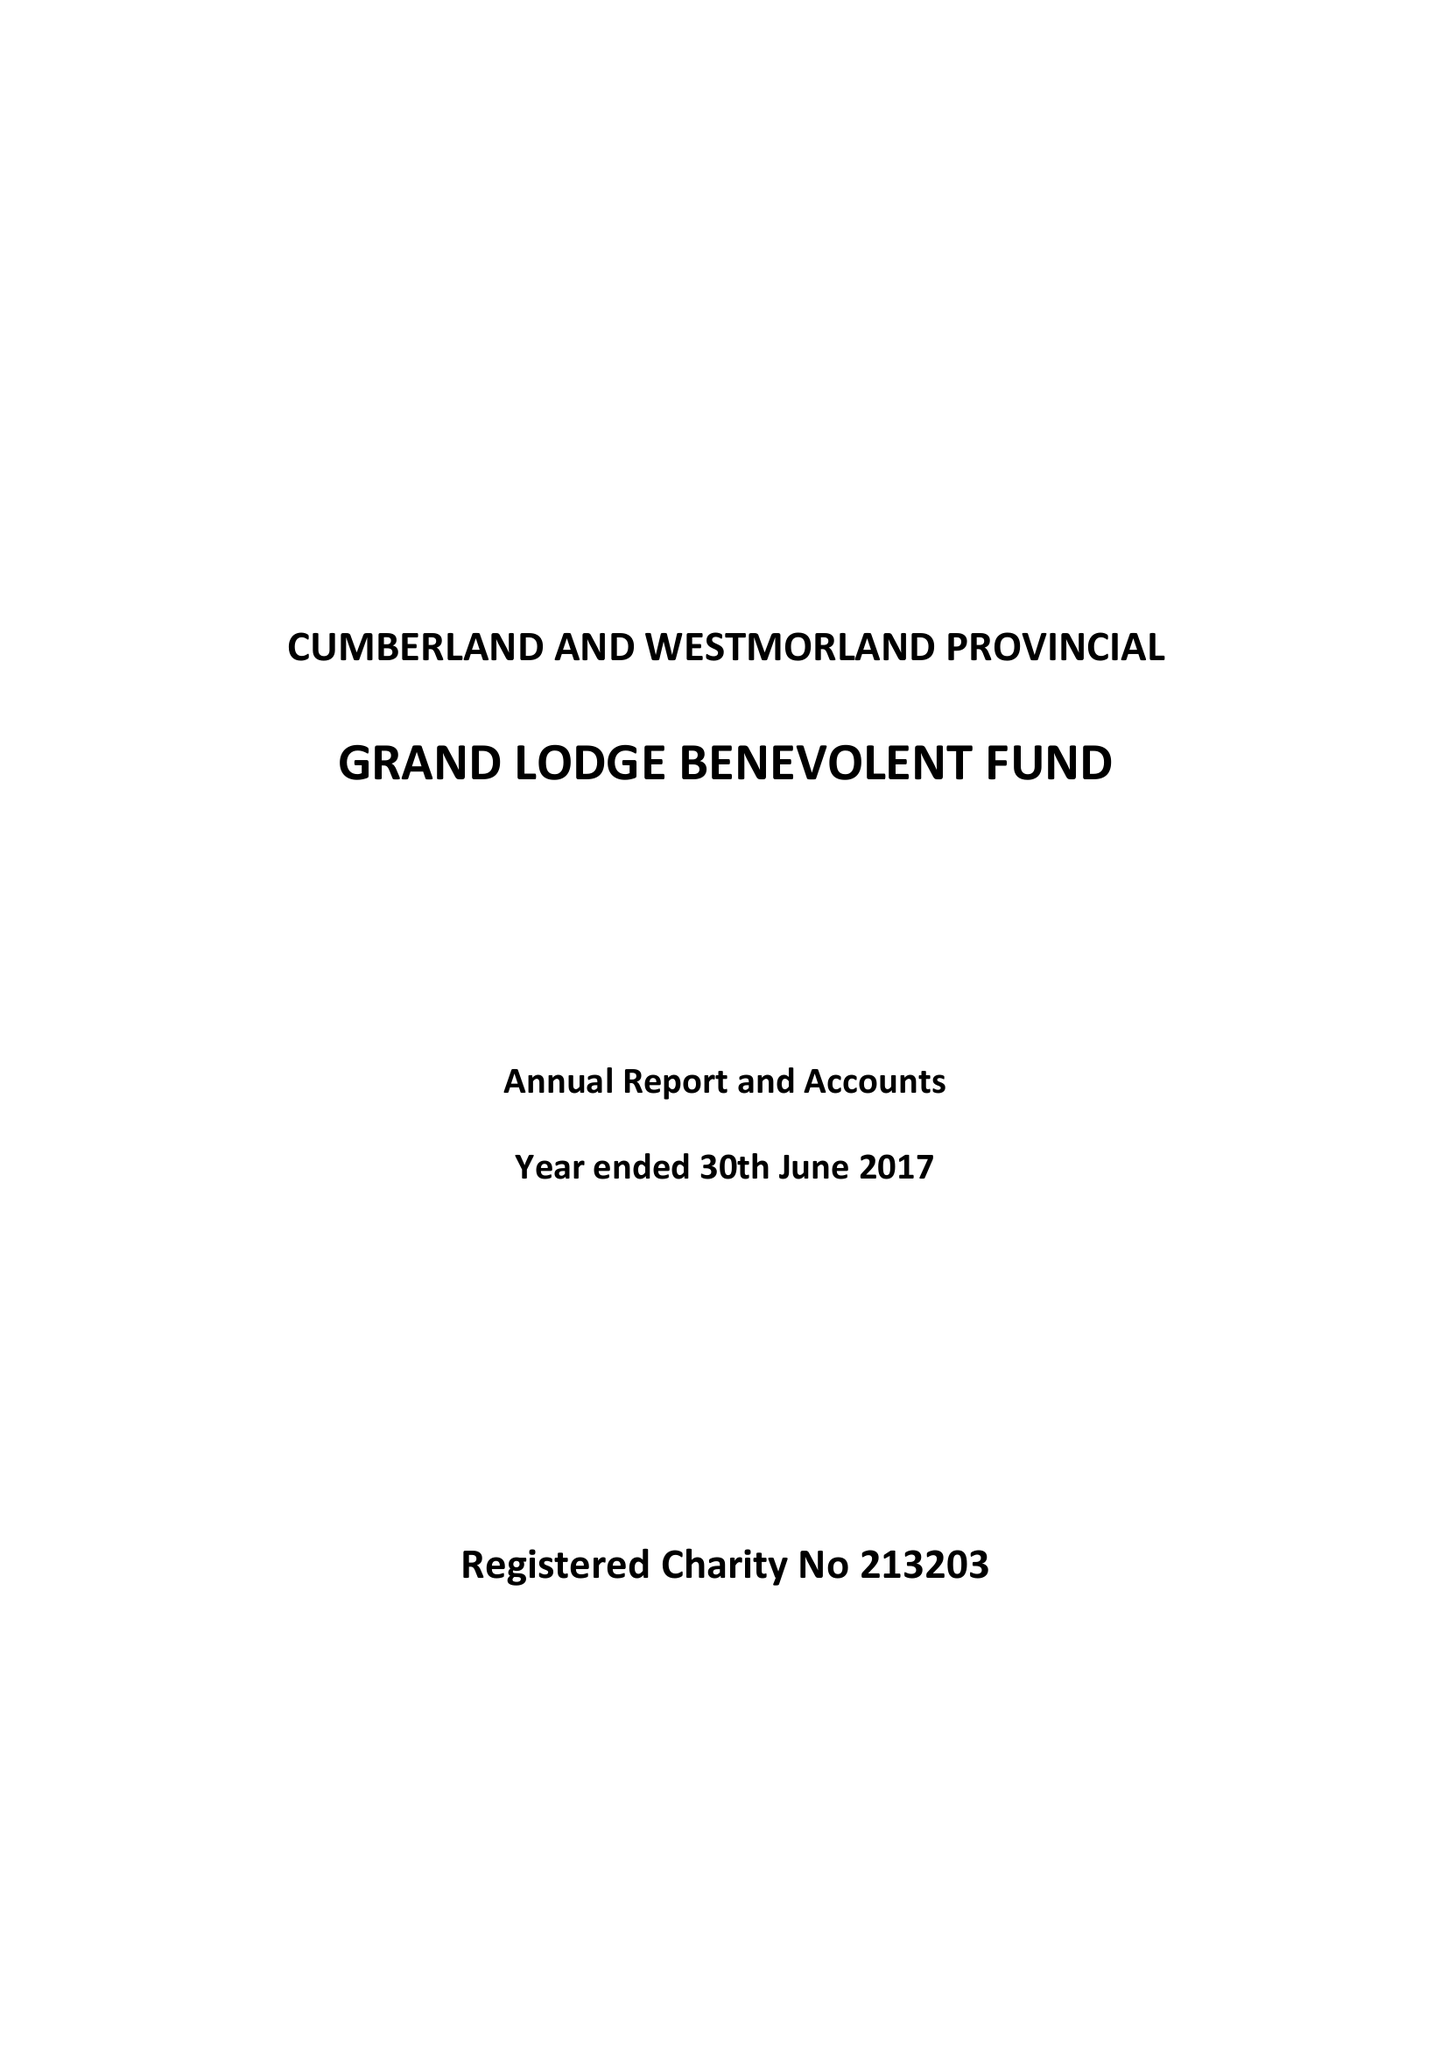What is the value for the address__post_town?
Answer the question using a single word or phrase. CARLISLE 